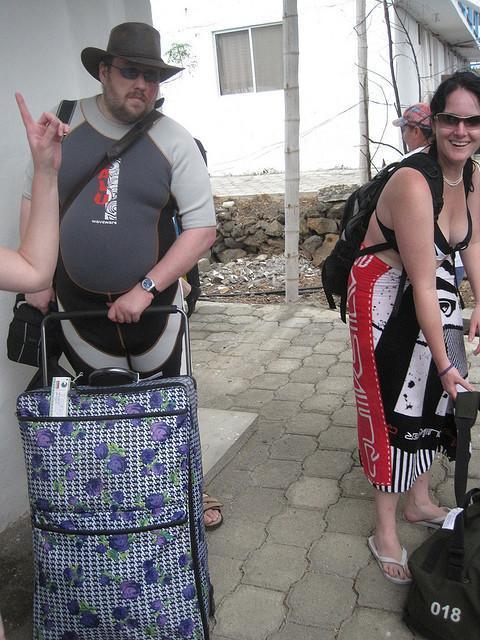How many people are visible?
Give a very brief answer. 3. 